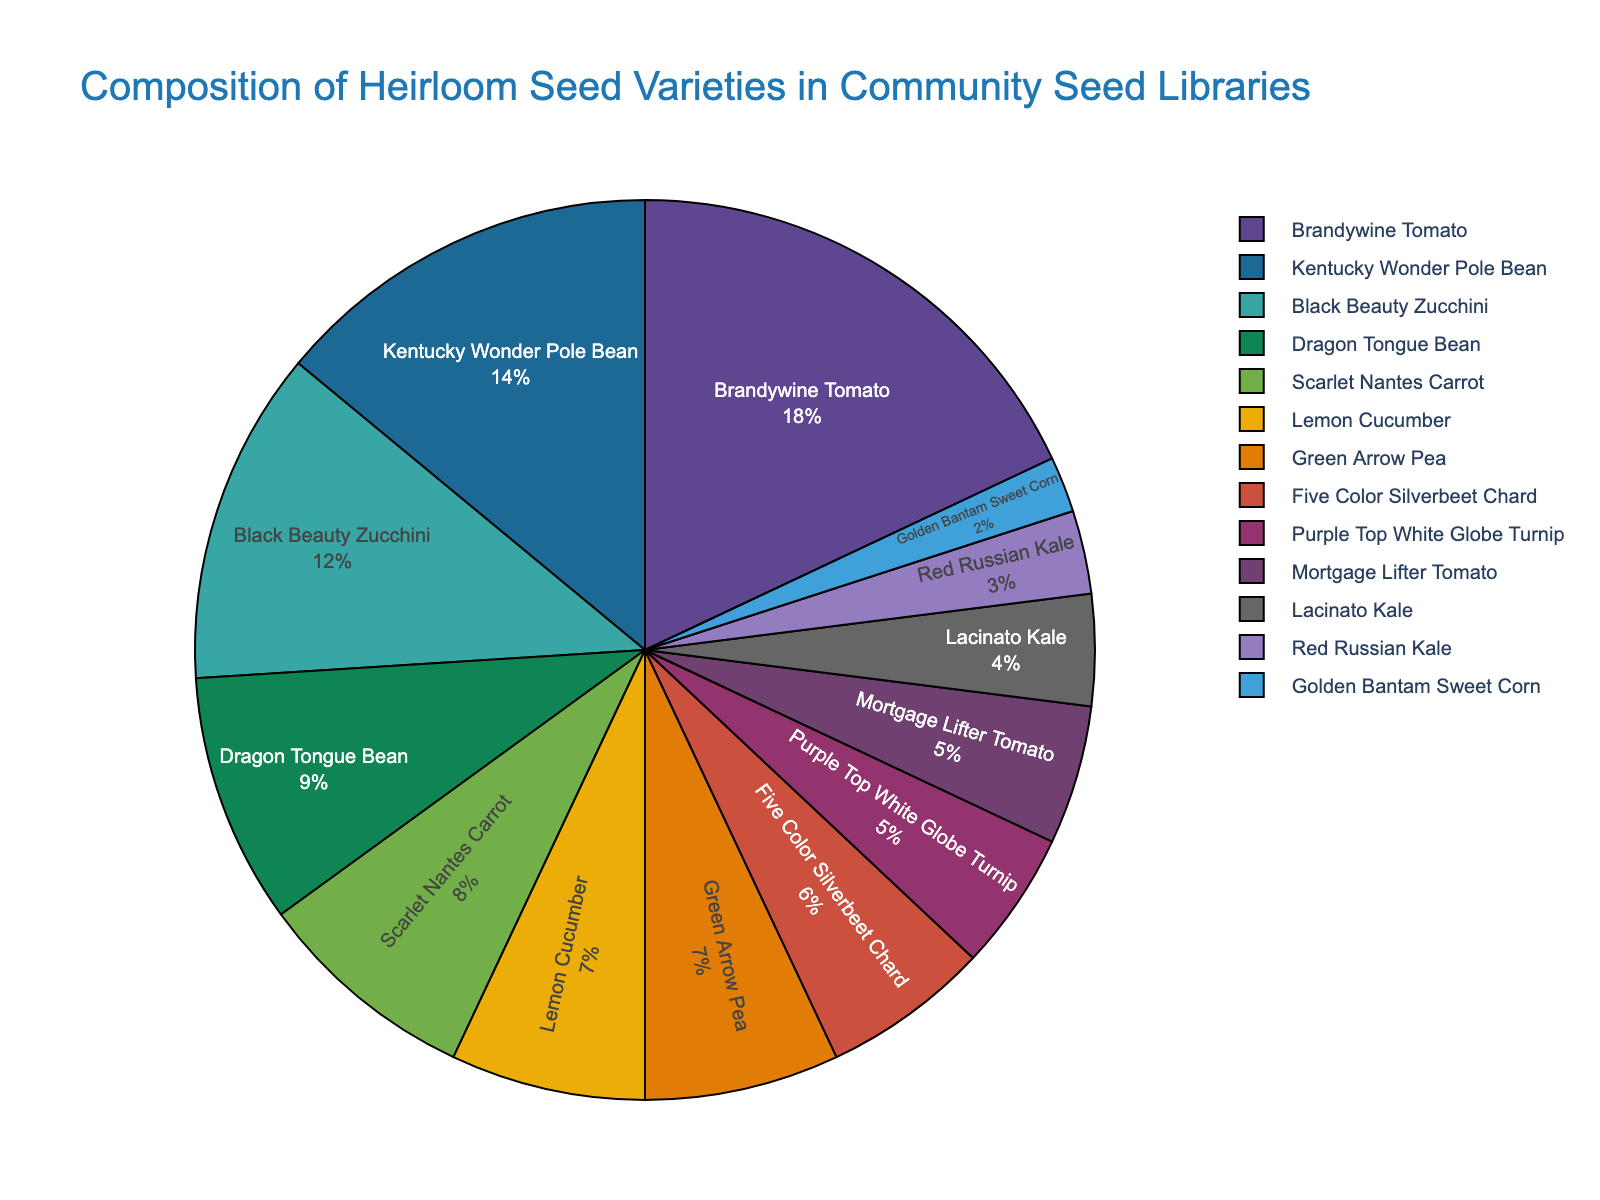What's the most common heirloom seed variety in the community seed libraries? The figure indicates the percentage composition of each heirloom seed variety. The variety with the largest percentage is the most common. Brandywine Tomato has the highest percentage at 18%.
Answer: Brandywine Tomato Which heirloom seed variety has a smaller percentage, Black Beauty Zucchini or Green Arrow Pea? Comparing the percentages, Black Beauty Zucchini is at 12% and Green Arrow Pea is at 7%. Green Arrow Pea has a smaller percentage.
Answer: Green Arrow Pea How many varieties have a percentage higher than 10%? Identify and count the varieties with percentages greater than 10%. Brandywine Tomato (18%), Kentucky Wonder Pole Bean (14%), and Black Beauty Zucchini (12%) are the varieties with percentages higher than 10%. There are 3 such varieties.
Answer: 3 What is the total percentage of all tomato varieties combined? Add up the percentages of all tomato varieties listed: Brandywine Tomato (18%) and Mortgage Lifter Tomato (5%). The total is 18% + 5% = 23%.
Answer: 23% Which variety has the equivalent percentage to Red Russian Kale? Look for a variety that shares the same percentage as Red Russian Kale, which is 3%. No other variety in the list has a 3% share.
Answer: None What is the combined percentage of all kale varieties? Sum the percentages of all kale varieties listed: Lacinato Kale (4%) and Red Russian Kale (3%). The total is 4% + 3% = 7%.
Answer: 7% Is the percentage of Dragon Tongue Bean greater than the combined percentage of Lacinato Kale and Scarlet Nantes Carrot? Compare the percentage of Dragon Tongue Bean (9%) with the total percentage of Lacinato Kale (4%) and Scarlet Nantes Carrot (8%). Combined, Lacinato Kale and Scarlet Nantes Carrot have 4% + 8% = 12%. Since 9% < 12%, Dragon Tongue Bean is not greater.
Answer: No Which has more varieties: those with percentages less than 6% or those with percentages greater than 10%? Count the varieties with percentages less than 6%: Purple Top White Globe Turnip (5%), Five Color Silverbeet Chard (6%), Lacinato Kale (4%), Red Russian Kale (3%), and Golden Bantam Sweet Corn (2%)—though Five Color Silverbeet Chard is exactly 6%. Now count those with percentages greater than 10%: Brandywine Tomato (18%), Kentucky Wonder Pole Bean (14%), and Black Beauty Zucchini (12%), which is 3. There are 5 varieties with less than 6% and 3 with more than 10%.
Answer: Percentages less than 6% What is the difference in percentage between Lemon Cucumber and Purple Top White Globe Turnip? Subtract the percentage of Purple Top White Globe Turnip (5%) from Lemon Cucumber (7%). The difference is 7% - 5% = 2%.
Answer: 2% If the least common variety doubled its percentage, would it surpass Five Color Silverbeet Chard? The least common variety is Golden Bantam Sweet Corn with 2%. Doubling 2% gives 4%, which is still less than Five Color Silverbeet Chard's 6%.
Answer: No 